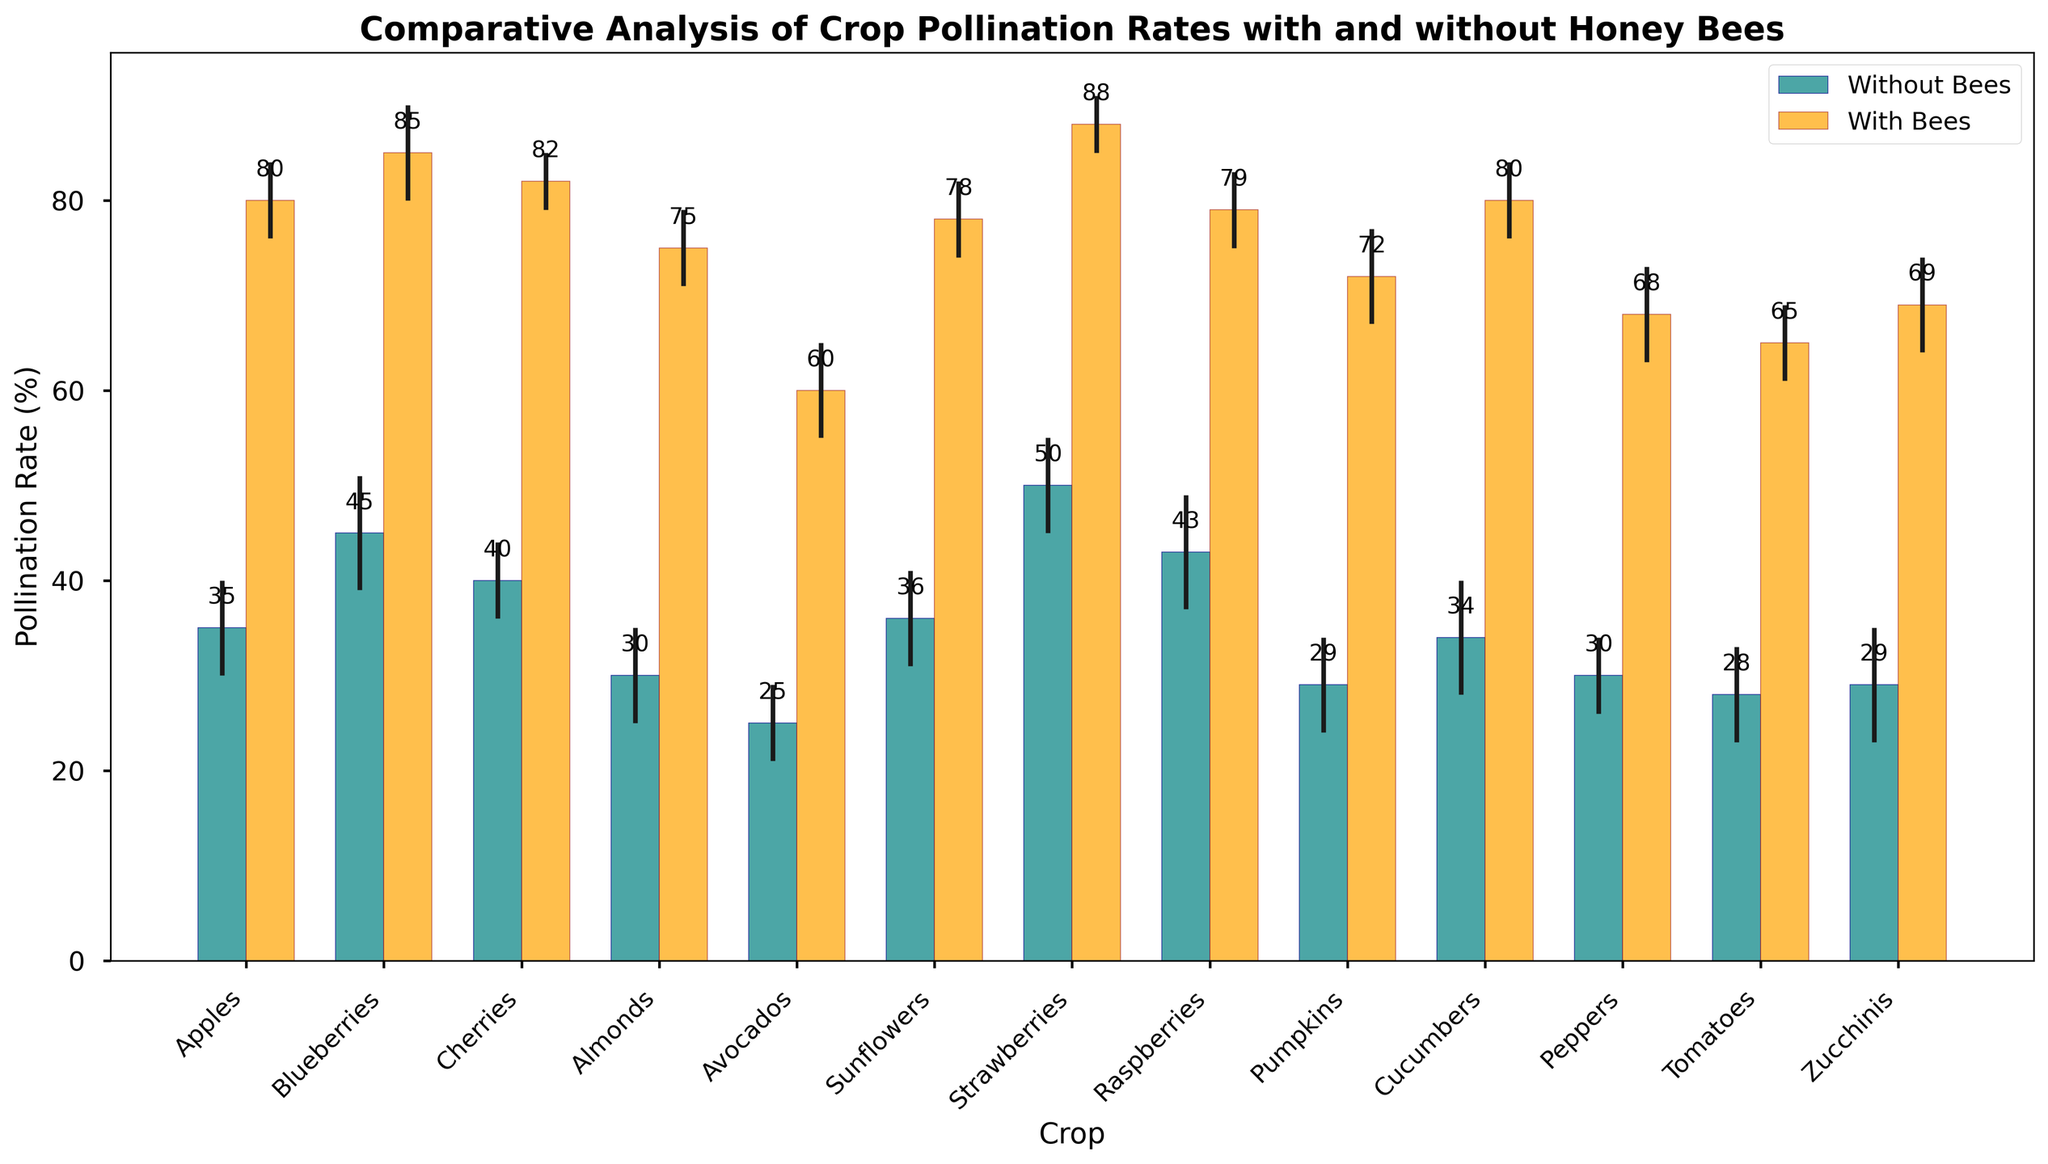Which crop has the highest pollination rate with bees? The highest bar in the "With Bees" group indicates the highest pollination rate with bees. The bar for Strawberries is the tallest in this group.
Answer: Strawberries Which crops have the same uncertain factor with and without bees? By examining the error bars, we can see which have the same height in both the "With Bees" and "Without Bees" group. Both Apples and Cherries have identical error bars with and without bees.
Answer: Apples, Cherries What is the difference in pollination rates for Tomātoes with bees and without bees? To find the difference, subtract the pollination rate of Tomatoes without bees (28%) from with bees (65%).
Answer: 37% Which crop shows the least improvement in pollination rate when bees are introduced? By calculating the difference between the pollination rates with and without bees for all crops, the smallest difference is noted for Peppers (68% - 30%).
Answer: Peppers What is the average pollination rate without bees for the listed crops? Sum all pollination rates without bees and divide by the number of crops: (35 + 45 + 40 + 30 + 25 + 36 + 50 + 43 + 29 + 34 + 30 + 28 + 29) / 13.
Answer: 34.23% Rank the crops from highest to lowest pollination rate with bees. Arrange the crops based on their pollination rates with bees: Strawberries, Blueberries, Cucumbers, Apples, Cherries, Sunflowers, Raspberries, Almonds, Pumpkins, Zucchinis, Peppers, Tomatoes, Avocados.
Answer: Strawberries > Blueberries > Cucumbers > Apples > Cherries > Sunflowers > Raspberries > Almonds > Pumpkins > Zucchinis > Peppers > Tomatoes > Avocados Which crop has the greatest uncertain factor with bees? The crop with the highest error bar in the "With Bees" group is Blueberries.
Answer: Blueberries What is the median pollination rate for the crops without bees? The sorted pollination rates without bees are: 25, 28, 29, 29, 30, 30, 34, 35, 36, 40, 43, 45, 50. The median is the middle value of this list, which is 34%.
Answer: 34% How much more is the pollination rate of Zucchinis with bees compared to without bees? By subtracting the pollination rate of Zucchinis without bees (29%) from with bees (69%), we get the difference.
Answer: 40% 